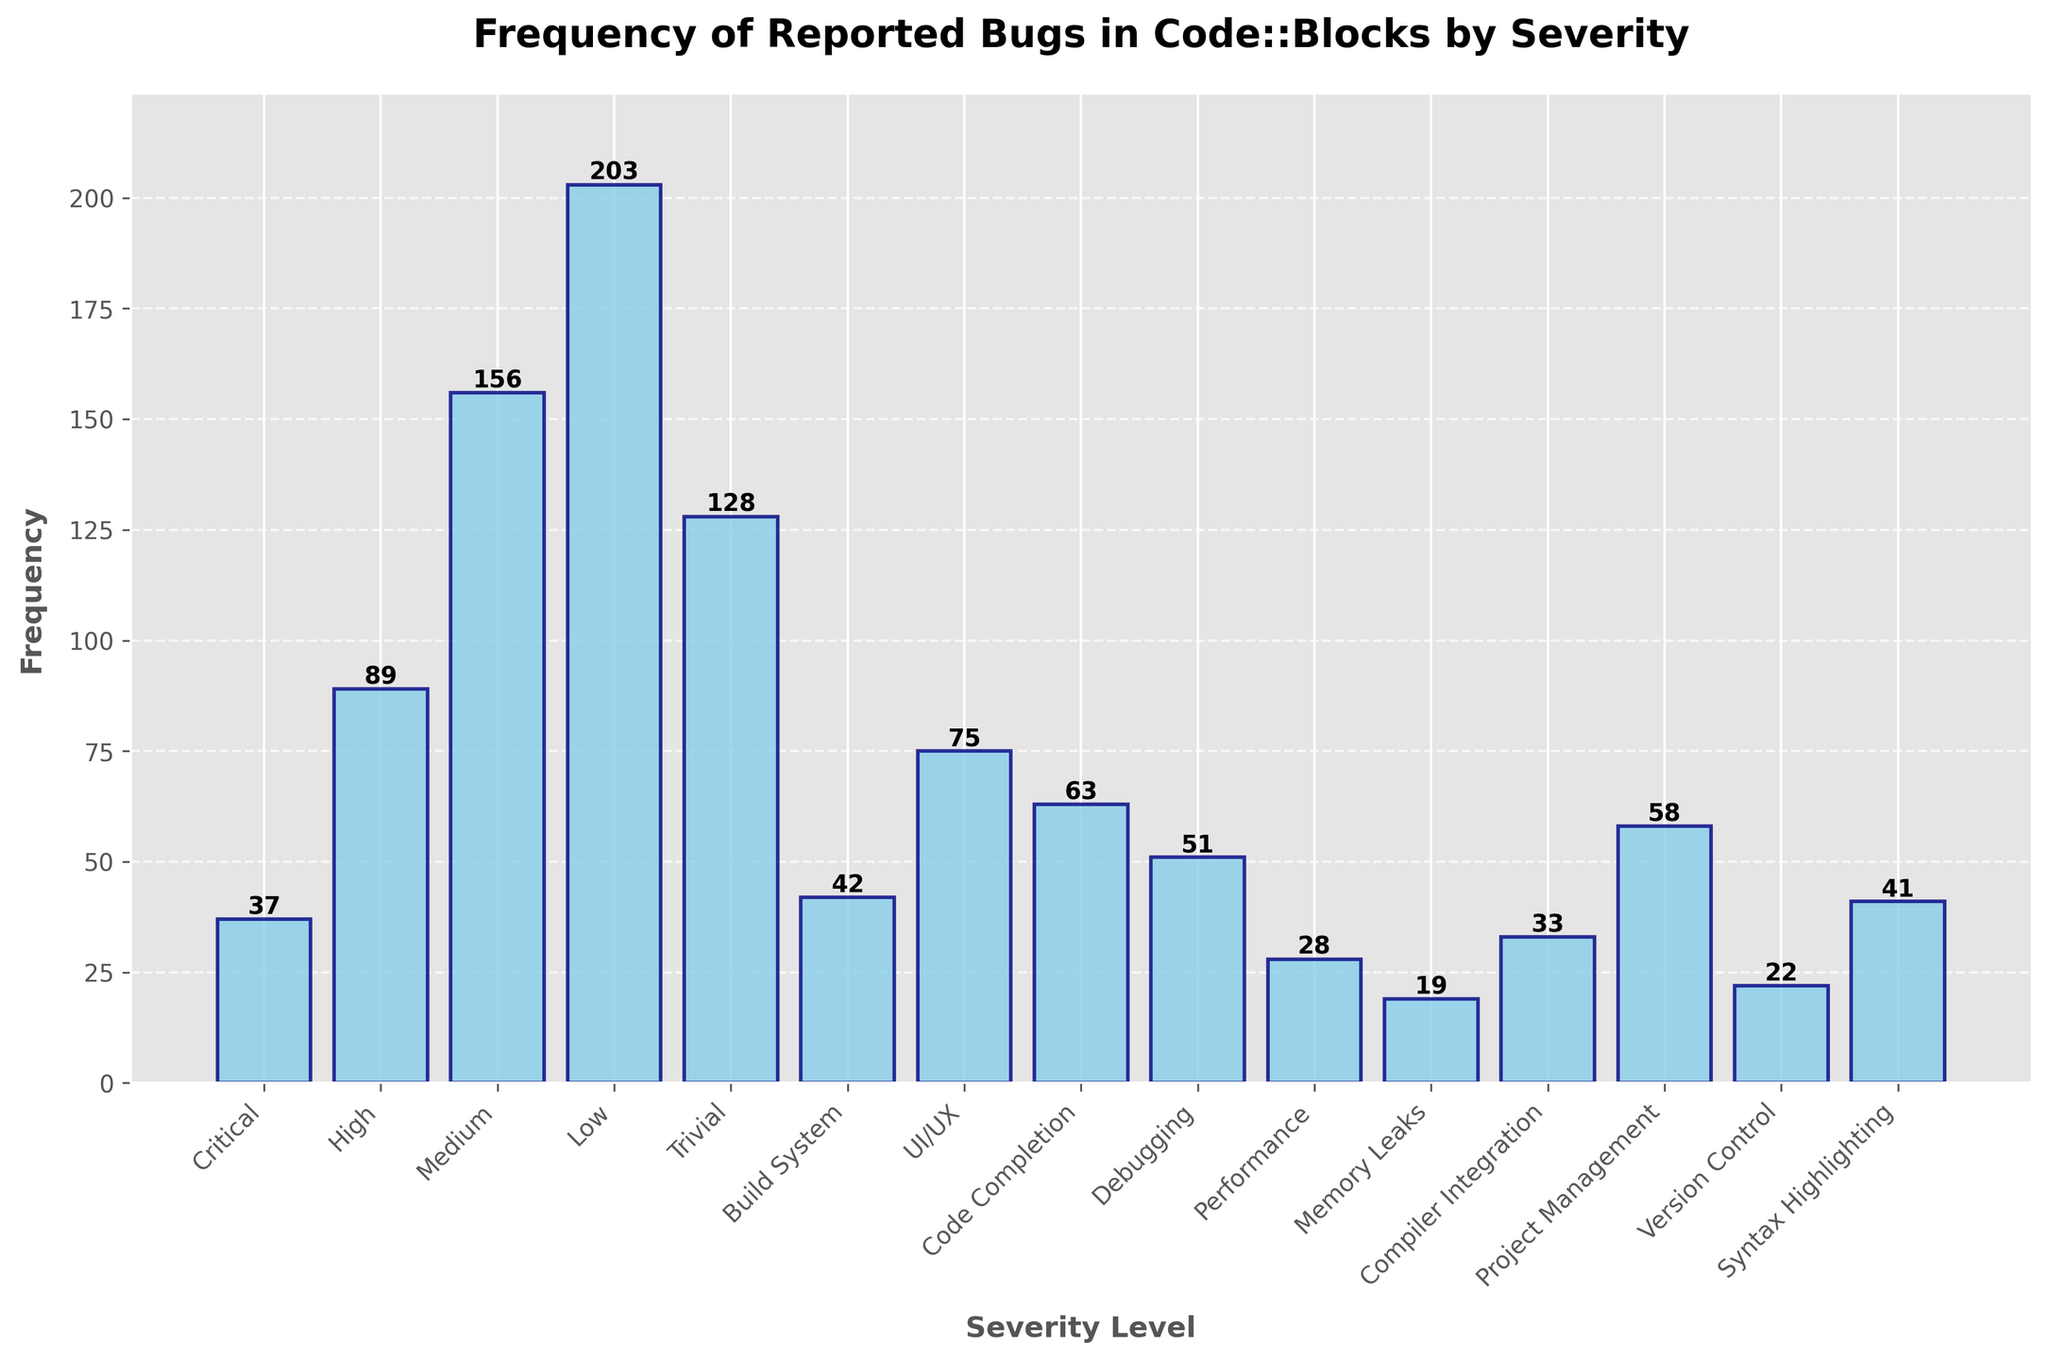Which severity level has the highest frequency of reported bugs? By examining the height of the bars, the 'Low' severity level has the tallest bar, indicating it has the highest frequency of reported bugs.
Answer: Low What's the total number of reported bugs for 'Critical', 'Medium', and 'Low' severity levels combined? Sum the frequencies of the 'Critical', 'Medium', and 'Low' severity levels. (37 for Critical) + (156 for Medium) + (203 for Low) = 396
Answer: 396 Which severity level has a lower frequency of reported bugs, 'Build System' or 'Compiler Integration'? Compare the heights of the bars labeled 'Build System' and 'Compiler Integration'. 'Build System' has a taller bar than 'Compiler Integration', indicating it has a higher frequency. Therefore, 'Compiler Integration' has a lower frequency.
Answer: Compiler Integration How much higher is the frequency of 'Medium' severity bugs compared to 'Critical' severity bugs? Subtract the frequency of 'Critical' severity bugs from the frequency of 'Medium' severity bugs. 156 (Medium) - 37 (Critical) = 119
Answer: 119 Which category has the least reported bugs, and how many are there? Identify the shortest bar in the chart. The 'Memory Leaks' category has the shortest bar, indicating it has the least reported bugs, which is 19.
Answer: Memory Leaks, 19 Are there more bugs reported in 'Code Completion' or 'Debugging'? Compare the heights of the 'Code Completion' and 'Debugging' bars. The 'Code Completion' bar is taller, indicating a higher frequency of bugs compared to 'Debugging'.
Answer: Code Completion What is the difference in frequency between 'UI/UX' and 'Project Management' categories? Subtract the frequency of 'Project Management' bugs from the frequency of 'UI/UX' bugs. 75 (UI/UX) - 58 (Project Management) = 17
Answer: 17 List the severity levels in decreasing order of the number of reported bugs. Arrange the severity levels based on the heights of the bars from tallest to shortest. The order is: Low, Medium, High, Trivial, Critical.
Answer: Low, Medium, High, Trivial, Critical What’s the combined frequency of bugs in 'Performance', 'Memory Leaks', and 'Version Control'? Sum the frequencies of 'Performance', 'Memory Leaks', and 'Version Control'. (28 for Performance) + (19 for Memory Leaks) + (22 for Version Control) = 69
Answer: 69 Which category has more reported bugs, 'Syntax Highlighting' or 'Build System'? Compare the heights of the bars for 'Syntax Highlighting' and 'Build System'. The 'Syntax Highlighting' bar is slightly taller, indicating a higher frequency than 'Build System'.
Answer: Syntax Highlighting 